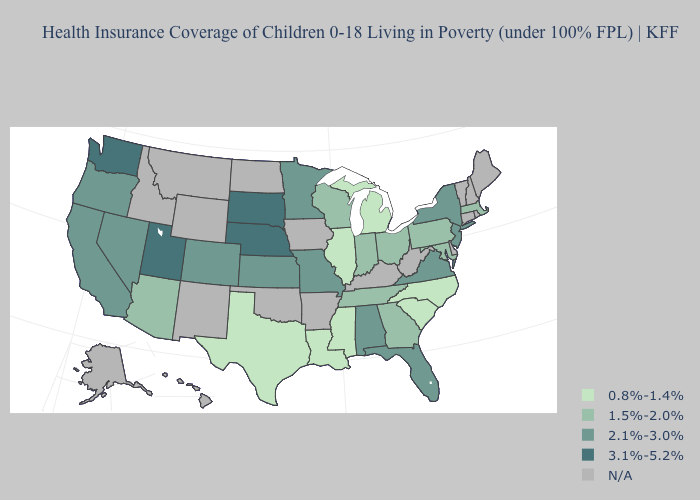Which states have the lowest value in the South?
Short answer required. Louisiana, Mississippi, North Carolina, South Carolina, Texas. Name the states that have a value in the range 1.5%-2.0%?
Write a very short answer. Arizona, Georgia, Indiana, Maryland, Massachusetts, Ohio, Pennsylvania, Tennessee, Wisconsin. Name the states that have a value in the range 2.1%-3.0%?
Write a very short answer. Alabama, California, Colorado, Florida, Kansas, Minnesota, Missouri, Nevada, New Jersey, New York, Oregon, Virginia. How many symbols are there in the legend?
Give a very brief answer. 5. Which states have the highest value in the USA?
Give a very brief answer. Nebraska, South Dakota, Utah, Washington. Does the first symbol in the legend represent the smallest category?
Be succinct. Yes. What is the value of Massachusetts?
Write a very short answer. 1.5%-2.0%. Name the states that have a value in the range N/A?
Give a very brief answer. Alaska, Arkansas, Connecticut, Delaware, Hawaii, Idaho, Iowa, Kentucky, Maine, Montana, New Hampshire, New Mexico, North Dakota, Oklahoma, Rhode Island, Vermont, West Virginia, Wyoming. Name the states that have a value in the range N/A?
Give a very brief answer. Alaska, Arkansas, Connecticut, Delaware, Hawaii, Idaho, Iowa, Kentucky, Maine, Montana, New Hampshire, New Mexico, North Dakota, Oklahoma, Rhode Island, Vermont, West Virginia, Wyoming. Does Utah have the highest value in the West?
Quick response, please. Yes. How many symbols are there in the legend?
Keep it brief. 5. What is the lowest value in states that border Kansas?
Keep it brief. 2.1%-3.0%. What is the value of Alaska?
Be succinct. N/A. What is the value of Minnesota?
Keep it brief. 2.1%-3.0%. 